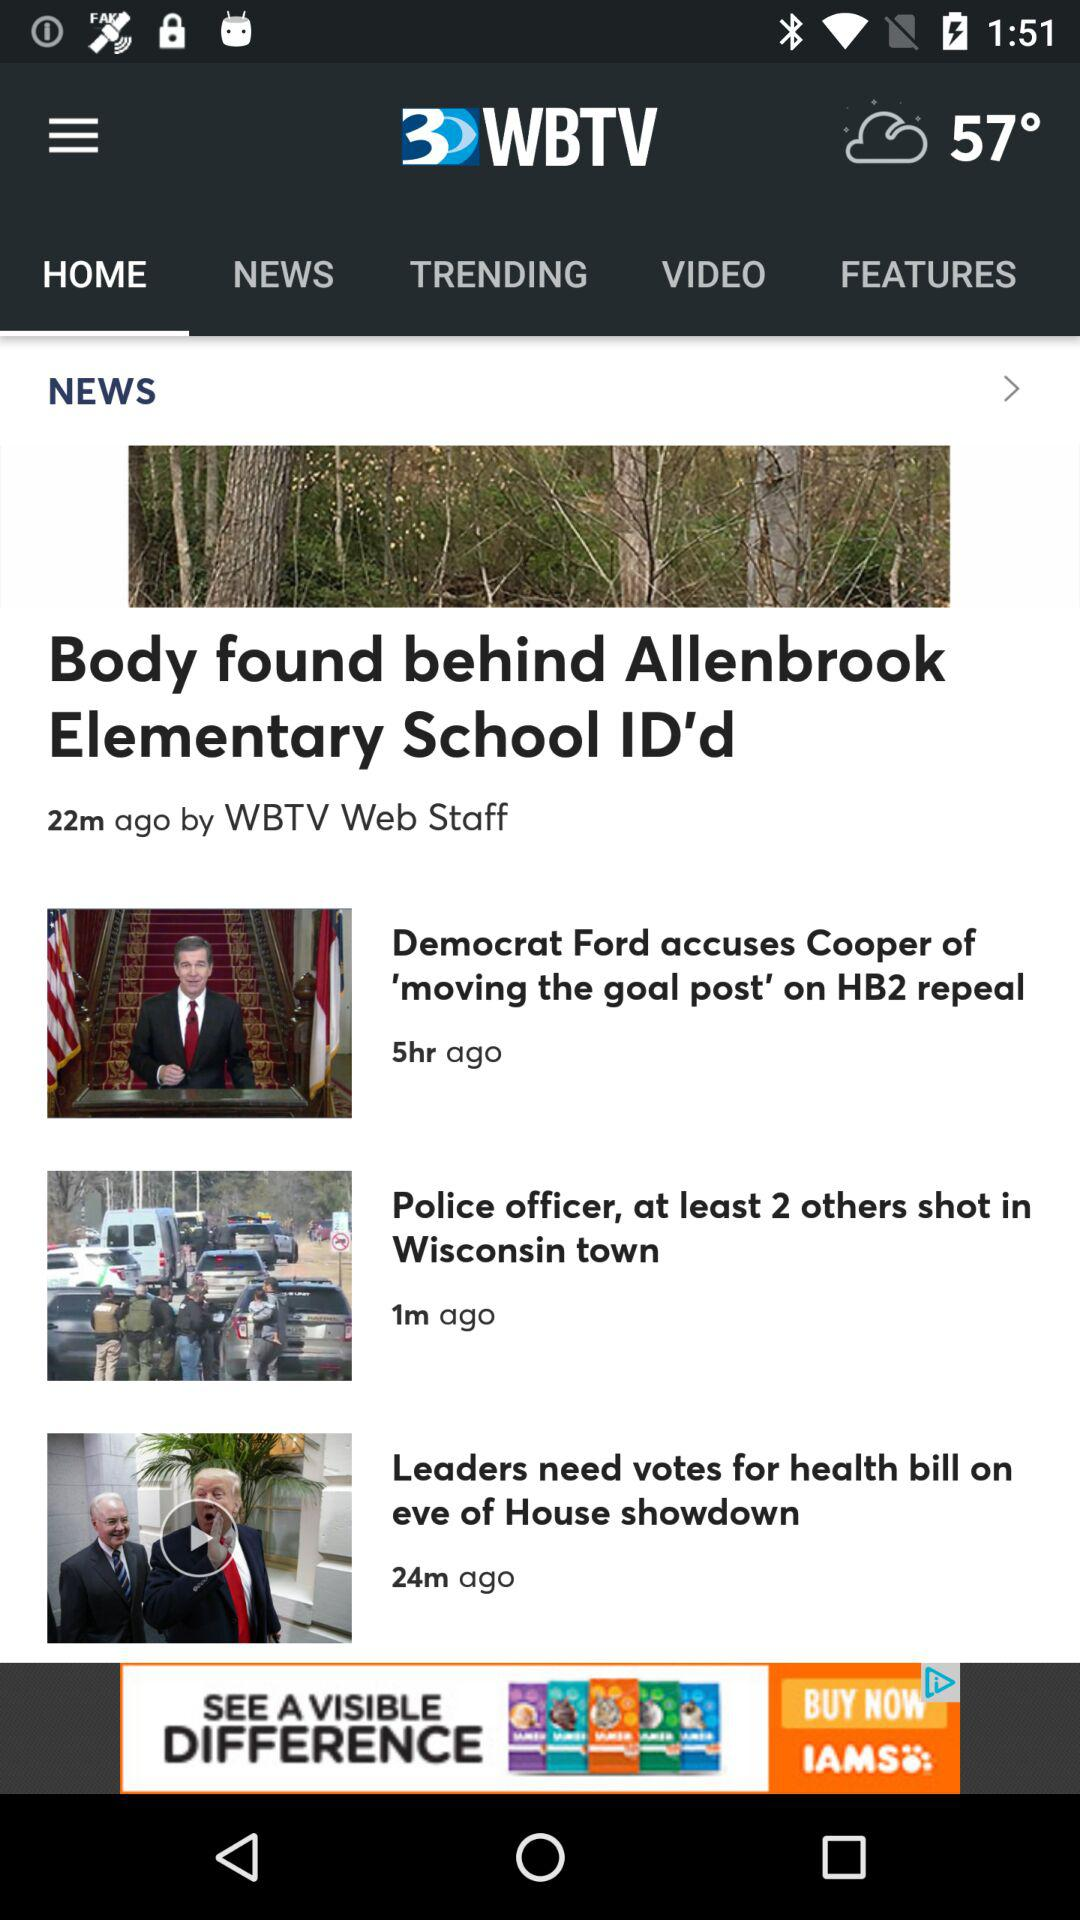What is the news headline that was published 22 minutes ago? The news headline published 22 minutes ago is "Body found behind Allenbrook Elementary School ID'd". 